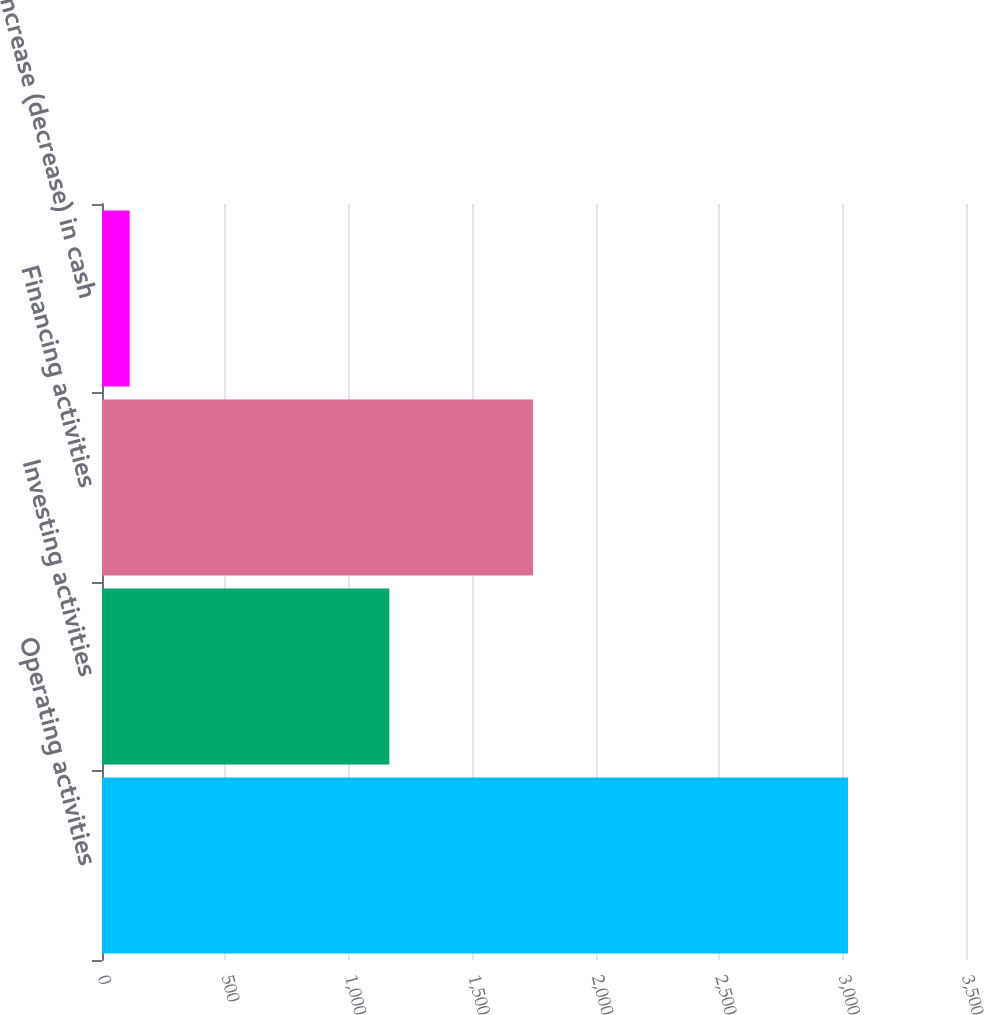Convert chart. <chart><loc_0><loc_0><loc_500><loc_500><bar_chart><fcel>Operating activities<fcel>Investing activities<fcel>Financing activities<fcel>Increase (decrease) in cash<nl><fcel>3022<fcel>1164<fcel>1746<fcel>112<nl></chart> 